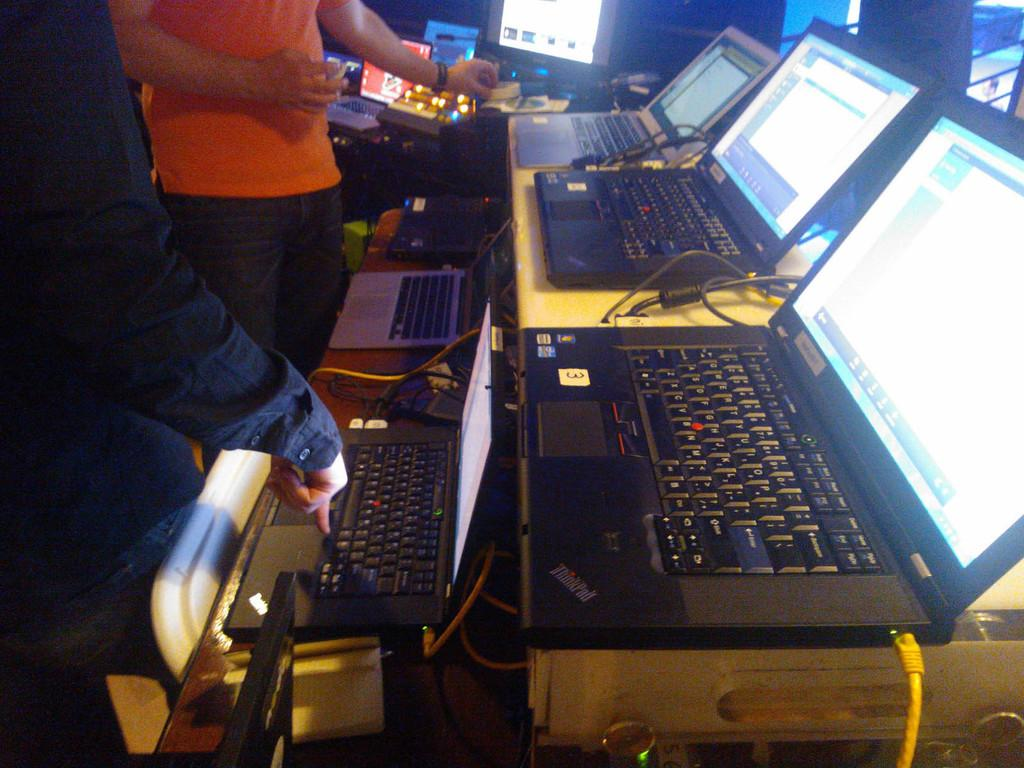<image>
Describe the image concisely. Two people looking at laptop computers, which happen to be ThinkPads. 